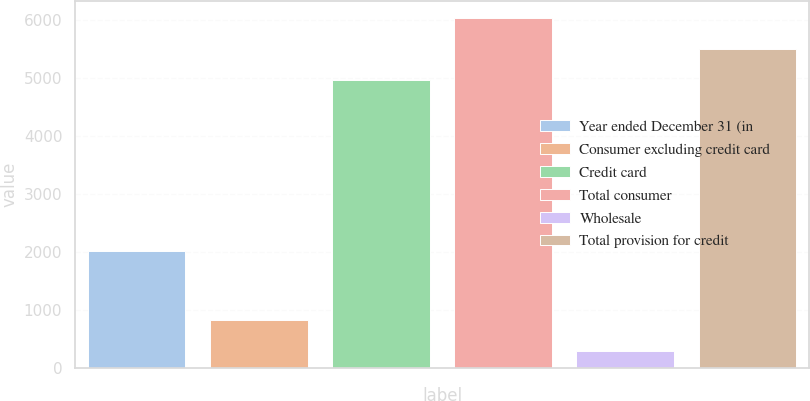<chart> <loc_0><loc_0><loc_500><loc_500><bar_chart><fcel>Year ended December 31 (in<fcel>Consumer excluding credit card<fcel>Credit card<fcel>Total consumer<fcel>Wholesale<fcel>Total provision for credit<nl><fcel>2017<fcel>832<fcel>4973<fcel>6031<fcel>303<fcel>5502<nl></chart> 